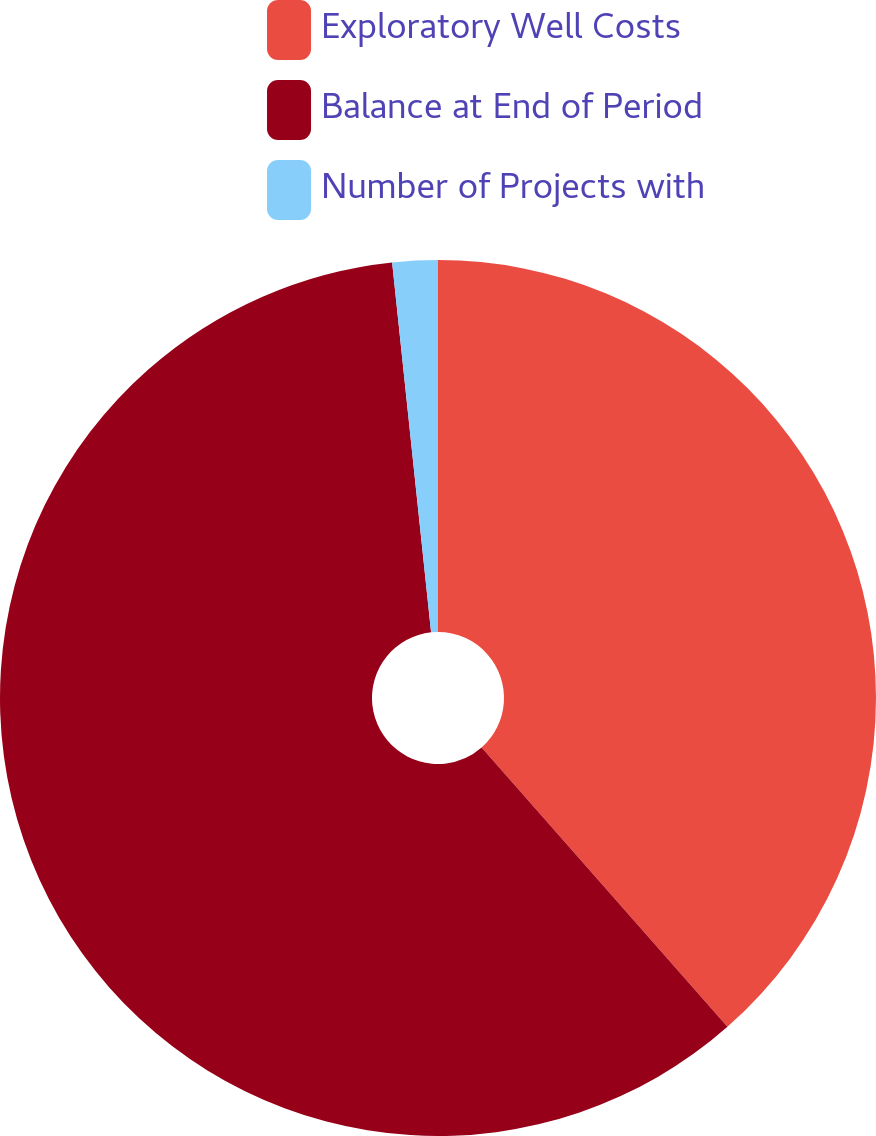<chart> <loc_0><loc_0><loc_500><loc_500><pie_chart><fcel>Exploratory Well Costs<fcel>Balance at End of Period<fcel>Number of Projects with<nl><fcel>38.51%<fcel>59.82%<fcel>1.67%<nl></chart> 